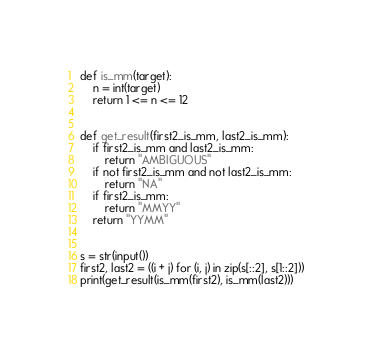Convert code to text. <code><loc_0><loc_0><loc_500><loc_500><_Python_>def is_mm(target):
    n = int(target)
    return 1 <= n <= 12


def get_result(first2_is_mm, last2_is_mm):
    if first2_is_mm and last2_is_mm:
        return "AMBIGUOUS"
    if not first2_is_mm and not last2_is_mm:
        return "NA"
    if first2_is_mm:
        return "MMYY"
    return "YYMM"


s = str(input())
first2, last2 = ((i + j) for (i, j) in zip(s[::2], s[1::2]))
print(get_result(is_mm(first2), is_mm(last2)))
</code> 